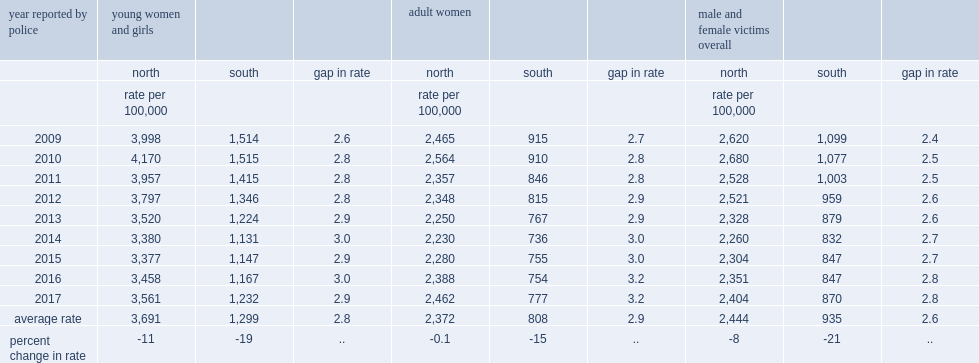Help me parse the entirety of this table. {'header': ['year reported by police', 'young women and girls', '', '', 'adult women', '', '', 'male and female victims overall', '', ''], 'rows': [['', 'north', 'south', 'gap in rate', 'north', 'south', 'gap in rate', 'north', 'south', 'gap in rate'], ['', 'rate per 100,000', '', '', 'rate per 100,000', '', '', 'rate per 100,000', '', ''], ['2009', '3,998', '1,514', '2.6', '2,465', '915', '2.7', '2,620', '1,099', '2.4'], ['2010', '4,170', '1,515', '2.8', '2,564', '910', '2.8', '2,680', '1,077', '2.5'], ['2011', '3,957', '1,415', '2.8', '2,357', '846', '2.8', '2,528', '1,003', '2.5'], ['2012', '3,797', '1,346', '2.8', '2,348', '815', '2.9', '2,521', '959', '2.6'], ['2013', '3,520', '1,224', '2.9', '2,250', '767', '2.9', '2,328', '879', '2.6'], ['2014', '3,380', '1,131', '3.0', '2,230', '736', '3.0', '2,260', '832', '2.7'], ['2015', '3,377', '1,147', '2.9', '2,280', '755', '3.0', '2,304', '847', '2.7'], ['2016', '3,458', '1,167', '3.0', '2,388', '754', '3.2', '2,351', '847', '2.8'], ['2017', '3,561', '1,232', '2.9', '2,462', '777', '3.2', '2,404', '870', '2.8'], ['average rate', '3,691', '1,299', '2.8', '2,372', '808', '2.9', '2,444', '935', '2.6'], ['percent change in rate', '-11', '-19', '..', '-0.1', '-15', '..', '-8', '-21', '..']]} While overall rates of violent crime against young females saw a net decline from 2009 to 2017, what was the decrease for young females in the north? -11.0. While overall rates of violent crime against young females saw a net decline from 2009 to 2017, what was the decrease for young females in the south? -19.0. 